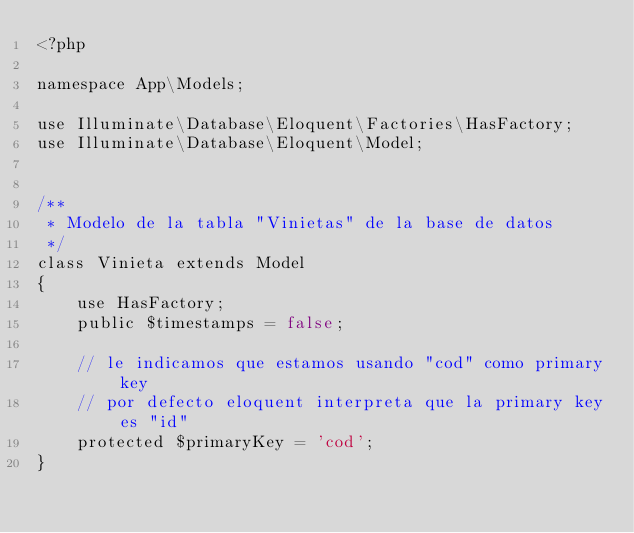Convert code to text. <code><loc_0><loc_0><loc_500><loc_500><_PHP_><?php

namespace App\Models;

use Illuminate\Database\Eloquent\Factories\HasFactory;
use Illuminate\Database\Eloquent\Model;


/**
 * Modelo de la tabla "Vinietas" de la base de datos
 */
class Vinieta extends Model
{
    use HasFactory;
    public $timestamps = false;

    // le indicamos que estamos usando "cod" como primary key
    // por defecto eloquent interpreta que la primary key es "id"
    protected $primaryKey = 'cod';
}
</code> 